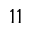<formula> <loc_0><loc_0><loc_500><loc_500>1 1</formula> 